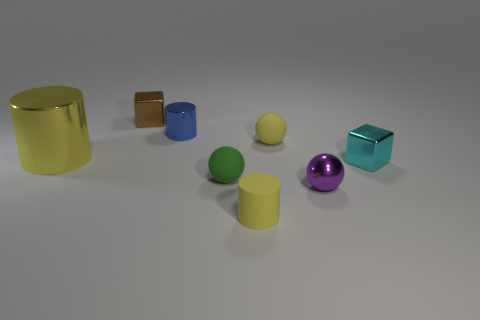Subtract all small cylinders. How many cylinders are left? 1 Subtract all green blocks. How many yellow cylinders are left? 2 Add 2 big metallic things. How many objects exist? 10 Subtract all spheres. How many objects are left? 5 Subtract all blue cylinders. How many cylinders are left? 2 Subtract 2 cylinders. How many cylinders are left? 1 Subtract all red balls. Subtract all yellow blocks. How many balls are left? 3 Subtract all cyan rubber spheres. Subtract all small yellow matte cylinders. How many objects are left? 7 Add 6 large metallic things. How many large metallic things are left? 7 Add 1 tiny green balls. How many tiny green balls exist? 2 